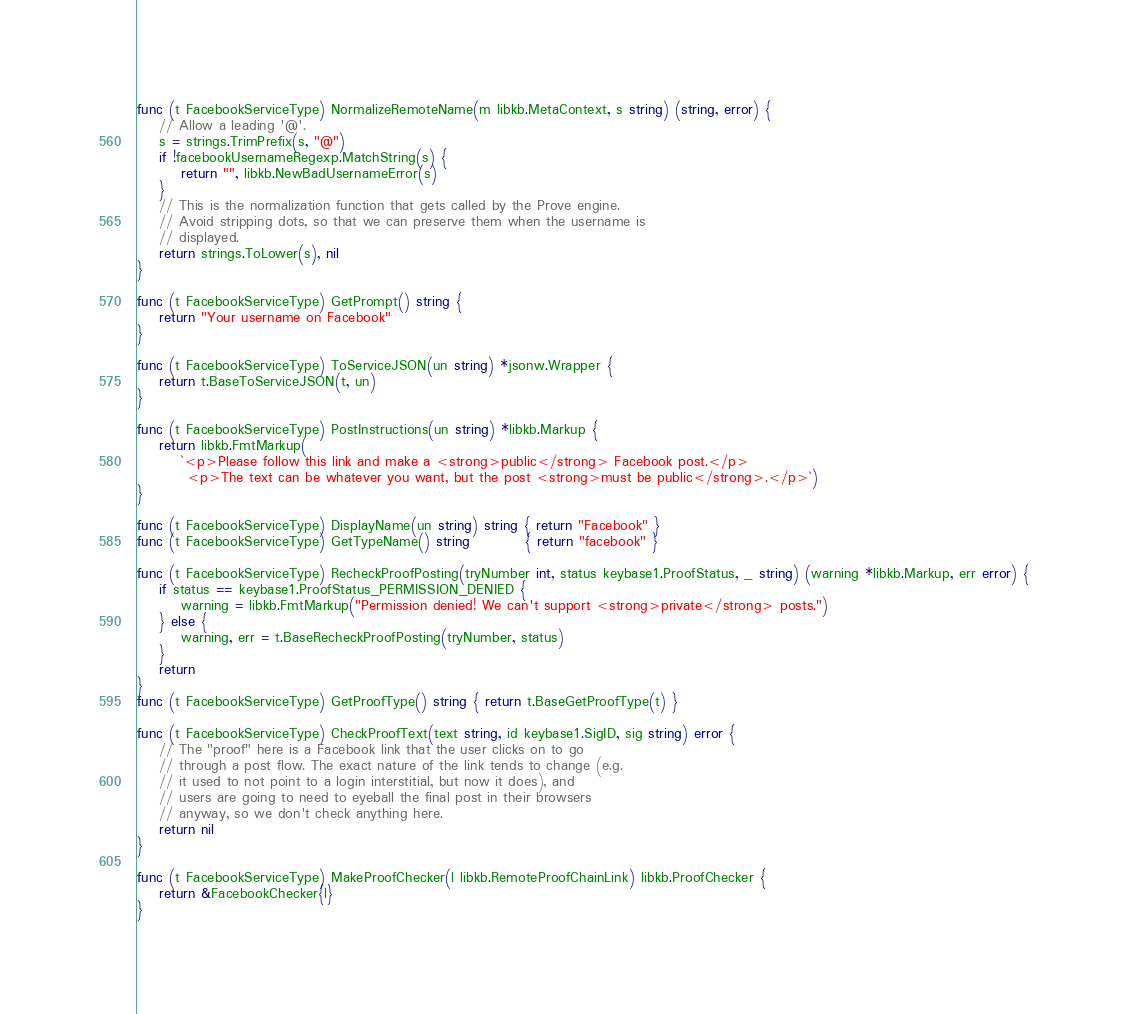Convert code to text. <code><loc_0><loc_0><loc_500><loc_500><_Go_>
func (t FacebookServiceType) NormalizeRemoteName(m libkb.MetaContext, s string) (string, error) {
	// Allow a leading '@'.
	s = strings.TrimPrefix(s, "@")
	if !facebookUsernameRegexp.MatchString(s) {
		return "", libkb.NewBadUsernameError(s)
	}
	// This is the normalization function that gets called by the Prove engine.
	// Avoid stripping dots, so that we can preserve them when the username is
	// displayed.
	return strings.ToLower(s), nil
}

func (t FacebookServiceType) GetPrompt() string {
	return "Your username on Facebook"
}

func (t FacebookServiceType) ToServiceJSON(un string) *jsonw.Wrapper {
	return t.BaseToServiceJSON(t, un)
}

func (t FacebookServiceType) PostInstructions(un string) *libkb.Markup {
	return libkb.FmtMarkup(
		`<p>Please follow this link and make a <strong>public</strong> Facebook post.</p>
		 <p>The text can be whatever you want, but the post <strong>must be public</strong>.</p>`)
}

func (t FacebookServiceType) DisplayName(un string) string { return "Facebook" }
func (t FacebookServiceType) GetTypeName() string          { return "facebook" }

func (t FacebookServiceType) RecheckProofPosting(tryNumber int, status keybase1.ProofStatus, _ string) (warning *libkb.Markup, err error) {
	if status == keybase1.ProofStatus_PERMISSION_DENIED {
		warning = libkb.FmtMarkup("Permission denied! We can't support <strong>private</strong> posts.")
	} else {
		warning, err = t.BaseRecheckProofPosting(tryNumber, status)
	}
	return
}
func (t FacebookServiceType) GetProofType() string { return t.BaseGetProofType(t) }

func (t FacebookServiceType) CheckProofText(text string, id keybase1.SigID, sig string) error {
	// The "proof" here is a Facebook link that the user clicks on to go
	// through a post flow. The exact nature of the link tends to change (e.g.
	// it used to not point to a login interstitial, but now it does), and
	// users are going to need to eyeball the final post in their browsers
	// anyway, so we don't check anything here.
	return nil
}

func (t FacebookServiceType) MakeProofChecker(l libkb.RemoteProofChainLink) libkb.ProofChecker {
	return &FacebookChecker{l}
}
</code> 